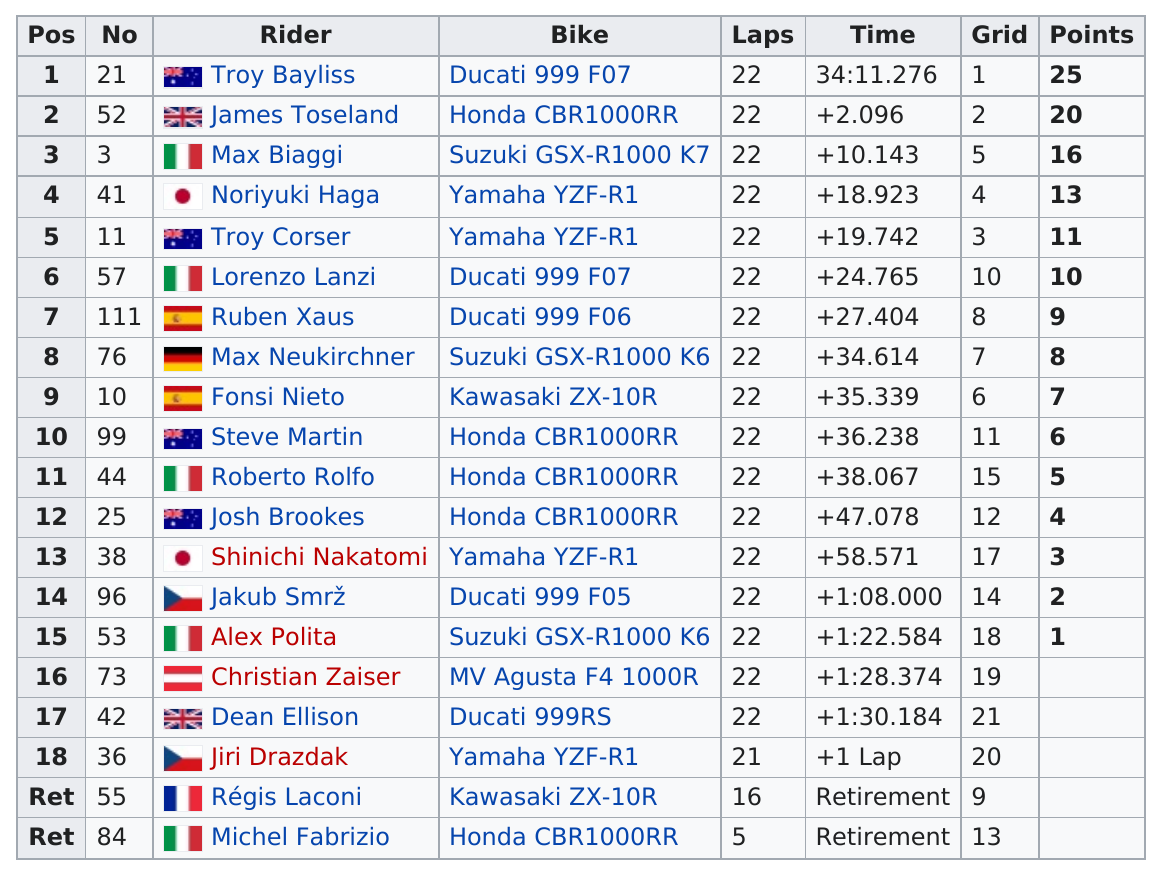Draw attention to some important aspects in this diagram. Out of the total number of racers, 5 of them did not score any points. In the competition, there were a total of 7 riders who scored at least 9 points. Troy Bayliss won the top position in the 2007 Phillip Island Superbike World Championship round Superbike race 1. James Toseland scored more points than Shinichi Nakatomi. In the 2007 Phillip Island Superbike World Championship round, the Superbike race 1 classification showed a point difference of 5 between the first and second positions. 